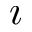Convert formula to latex. <formula><loc_0><loc_0><loc_500><loc_500>\imath</formula> 